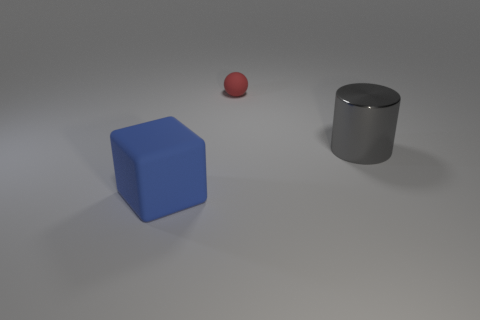If I wanted to move the cylinder, what would be the best way to grip it? Given the cylinder's smooth surface and size, the best way to grip it would likely be to wrap both hands around its body, ensuring a firm hold. 